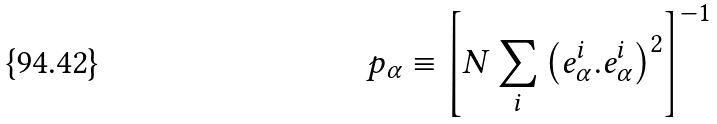<formula> <loc_0><loc_0><loc_500><loc_500>p _ { \alpha } \equiv \left [ N \sum _ { i } \left ( e _ { \alpha } ^ { i } . e _ { \alpha } ^ { i } \right ) ^ { 2 } \right ] ^ { - 1 }</formula> 